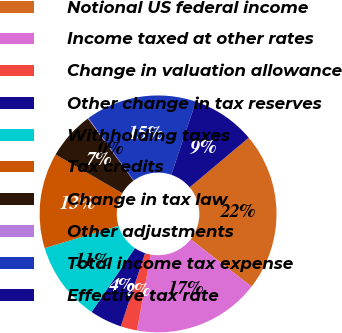Convert chart. <chart><loc_0><loc_0><loc_500><loc_500><pie_chart><fcel>Notional US federal income<fcel>Income taxed at other rates<fcel>Change in valuation allowance<fcel>Other change in tax reserves<fcel>Withholding taxes<fcel>Tax credits<fcel>Change in tax law<fcel>Other adjustments<fcel>Total income tax expense<fcel>Effective tax rate<nl><fcel>21.64%<fcel>17.33%<fcel>2.24%<fcel>4.39%<fcel>10.86%<fcel>13.02%<fcel>6.55%<fcel>0.08%<fcel>15.18%<fcel>8.71%<nl></chart> 